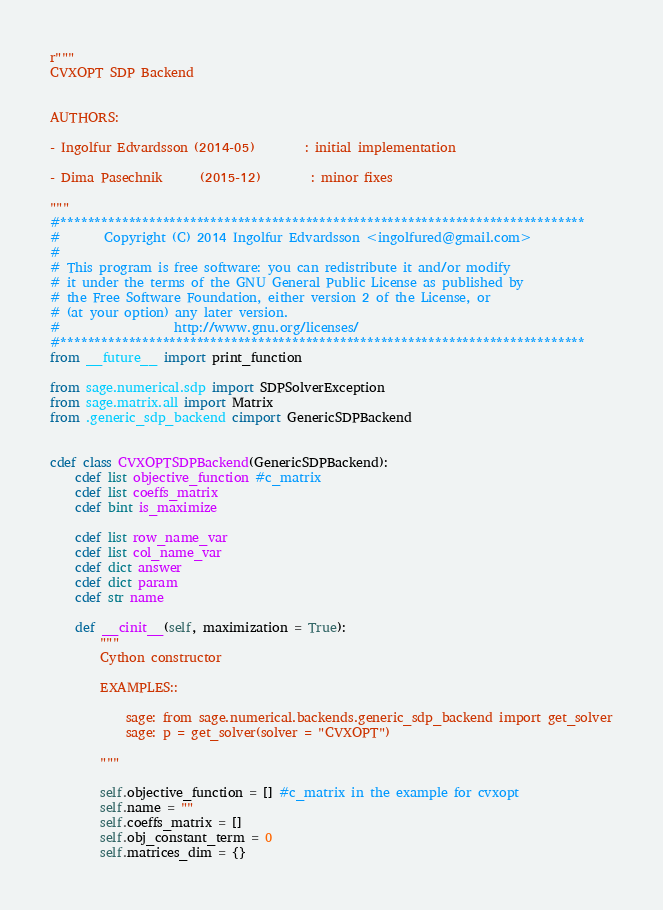Convert code to text. <code><loc_0><loc_0><loc_500><loc_500><_Cython_>r"""
CVXOPT SDP Backend


AUTHORS:

- Ingolfur Edvardsson (2014-05)        : initial implementation

- Dima Pasechnik      (2015-12)        : minor fixes

"""
#*****************************************************************************
#       Copyright (C) 2014 Ingolfur Edvardsson <ingolfured@gmail.com>
#
# This program is free software: you can redistribute it and/or modify
# it under the terms of the GNU General Public License as published by
# the Free Software Foundation, either version 2 of the License, or
# (at your option) any later version.
#                  http://www.gnu.org/licenses/
#*****************************************************************************
from __future__ import print_function

from sage.numerical.sdp import SDPSolverException
from sage.matrix.all import Matrix
from .generic_sdp_backend cimport GenericSDPBackend


cdef class CVXOPTSDPBackend(GenericSDPBackend):
    cdef list objective_function #c_matrix
    cdef list coeffs_matrix
    cdef bint is_maximize

    cdef list row_name_var
    cdef list col_name_var
    cdef dict answer
    cdef dict param
    cdef str name

    def __cinit__(self, maximization = True):
        """
        Cython constructor

        EXAMPLES::

            sage: from sage.numerical.backends.generic_sdp_backend import get_solver
            sage: p = get_solver(solver = "CVXOPT")

        """

        self.objective_function = [] #c_matrix in the example for cvxopt
        self.name = ""
        self.coeffs_matrix = []
        self.obj_constant_term = 0
        self.matrices_dim = {}</code> 